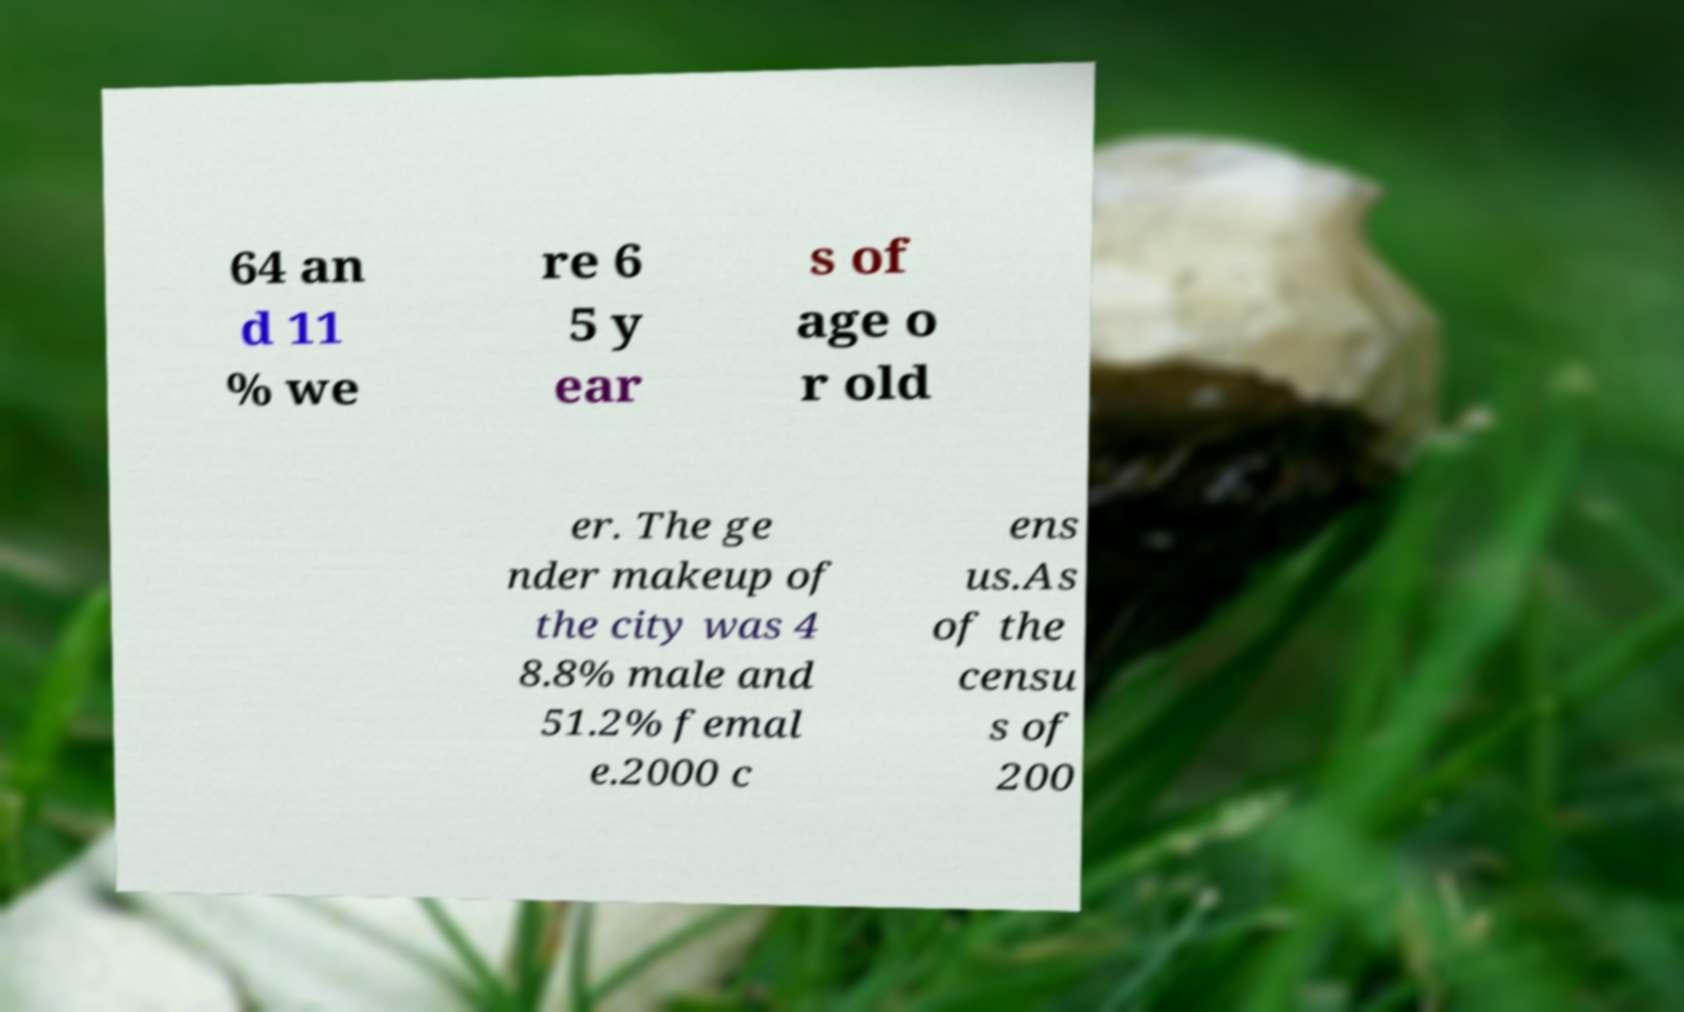There's text embedded in this image that I need extracted. Can you transcribe it verbatim? 64 an d 11 % we re 6 5 y ear s of age o r old er. The ge nder makeup of the city was 4 8.8% male and 51.2% femal e.2000 c ens us.As of the censu s of 200 